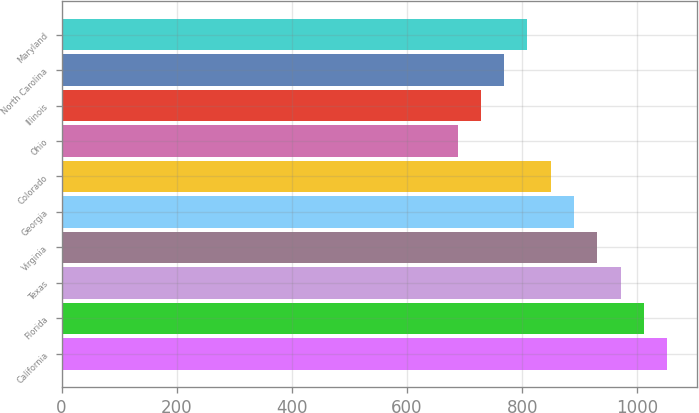<chart> <loc_0><loc_0><loc_500><loc_500><bar_chart><fcel>California<fcel>Florida<fcel>Texas<fcel>Virginia<fcel>Georgia<fcel>Colorado<fcel>Ohio<fcel>Illinois<fcel>North Carolina<fcel>Maryland<nl><fcel>1051.4<fcel>1011<fcel>970.6<fcel>930.2<fcel>889.8<fcel>849.4<fcel>687.8<fcel>728.2<fcel>768.6<fcel>809<nl></chart> 